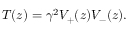Convert formula to latex. <formula><loc_0><loc_0><loc_500><loc_500>T ( z ) = \gamma ^ { 2 } V _ { + } ( z ) V _ { - } ( z ) .</formula> 